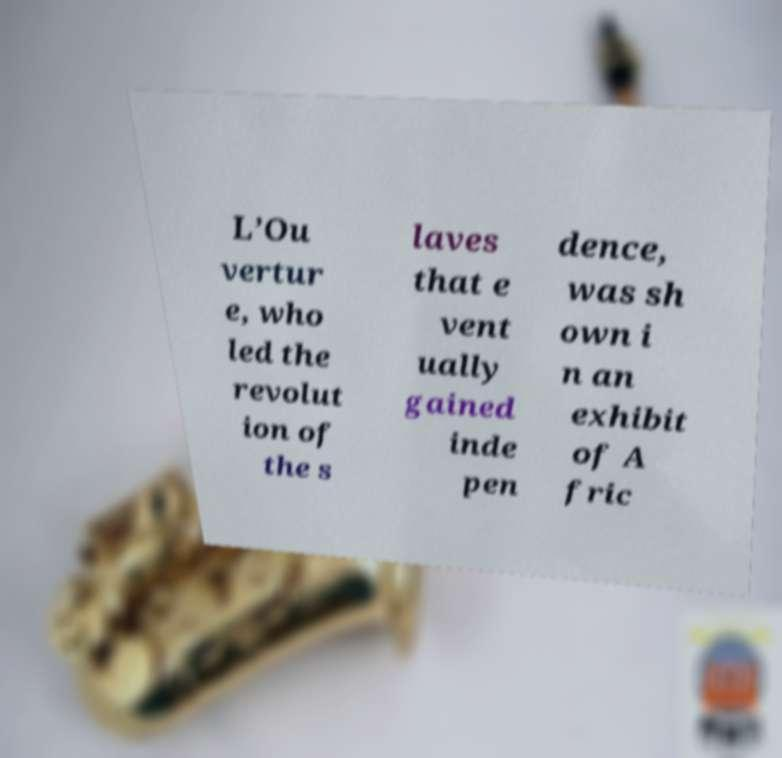Can you accurately transcribe the text from the provided image for me? L’Ou vertur e, who led the revolut ion of the s laves that e vent ually gained inde pen dence, was sh own i n an exhibit of A fric 